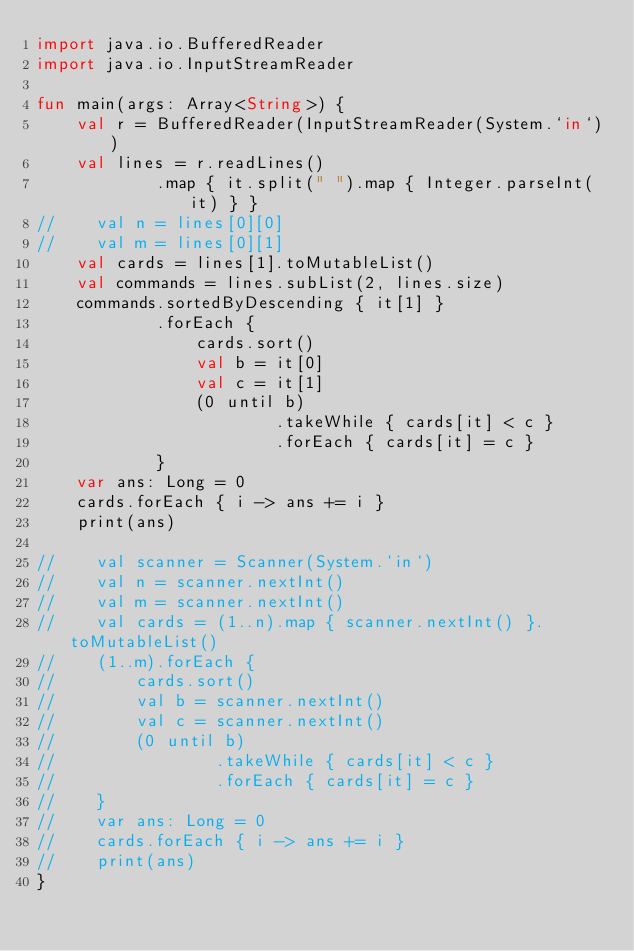Convert code to text. <code><loc_0><loc_0><loc_500><loc_500><_Kotlin_>import java.io.BufferedReader
import java.io.InputStreamReader

fun main(args: Array<String>) {
    val r = BufferedReader(InputStreamReader(System.`in`))
    val lines = r.readLines()
            .map { it.split(" ").map { Integer.parseInt(it) } }
//    val n = lines[0][0]
//    val m = lines[0][1]
    val cards = lines[1].toMutableList()
    val commands = lines.subList(2, lines.size)
    commands.sortedByDescending { it[1] }
            .forEach {
                cards.sort()
                val b = it[0]
                val c = it[1]
                (0 until b)
                        .takeWhile { cards[it] < c }
                        .forEach { cards[it] = c }
            }
    var ans: Long = 0
    cards.forEach { i -> ans += i }
    print(ans)

//    val scanner = Scanner(System.`in`)
//    val n = scanner.nextInt()
//    val m = scanner.nextInt()
//    val cards = (1..n).map { scanner.nextInt() }.toMutableList()
//    (1..m).forEach {
//        cards.sort()
//        val b = scanner.nextInt()
//        val c = scanner.nextInt()
//        (0 until b)
//                .takeWhile { cards[it] < c }
//                .forEach { cards[it] = c }
//    }
//    var ans: Long = 0
//    cards.forEach { i -> ans += i }
//    print(ans)
}
</code> 